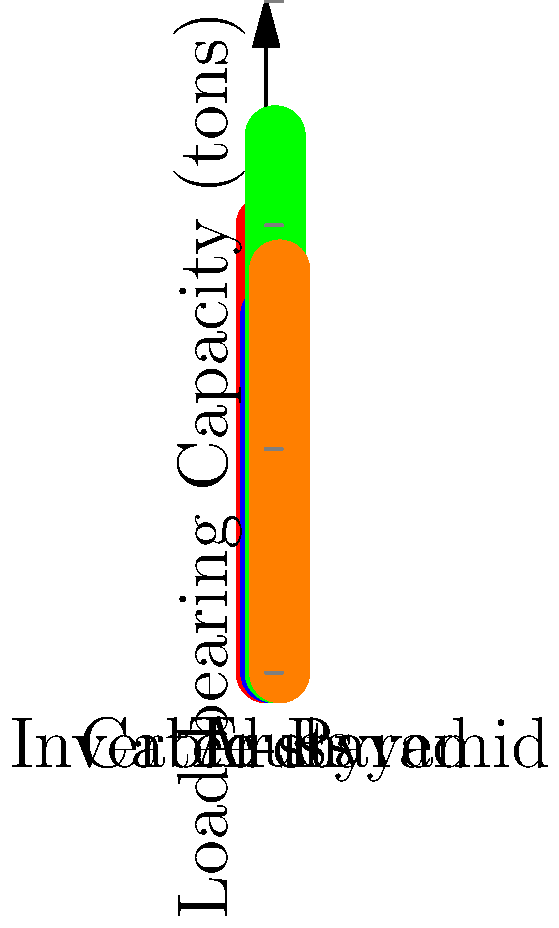In light of recent theories about unconventional engineering practices, compare the load-bearing capacities of four bridge designs: Arch, Truss, Cable-stayed, and the controversial Inverted Pyramid. Which design has the highest capacity, and how much more can it support compared to the lowest-capacity design? To solve this problem, we need to analyze the data presented in the graph:

1. Arch bridge: 100 tons
2. Truss bridge: 80 tons
3. Cable-stayed bridge: 120 tons
4. Inverted Pyramid bridge: 90 tons

Step 1: Identify the highest capacity design
The Cable-stayed bridge has the highest capacity at 120 tons.

Step 2: Identify the lowest capacity design
The Truss bridge has the lowest capacity at 80 tons.

Step 3: Calculate the difference
Difference = Highest capacity - Lowest capacity
$$120 \text{ tons} - 80 \text{ tons} = 40 \text{ tons}$$

Therefore, the Cable-stayed bridge can support 40 tons more than the Truss bridge.
Answer: Cable-stayed; 40 tons more 